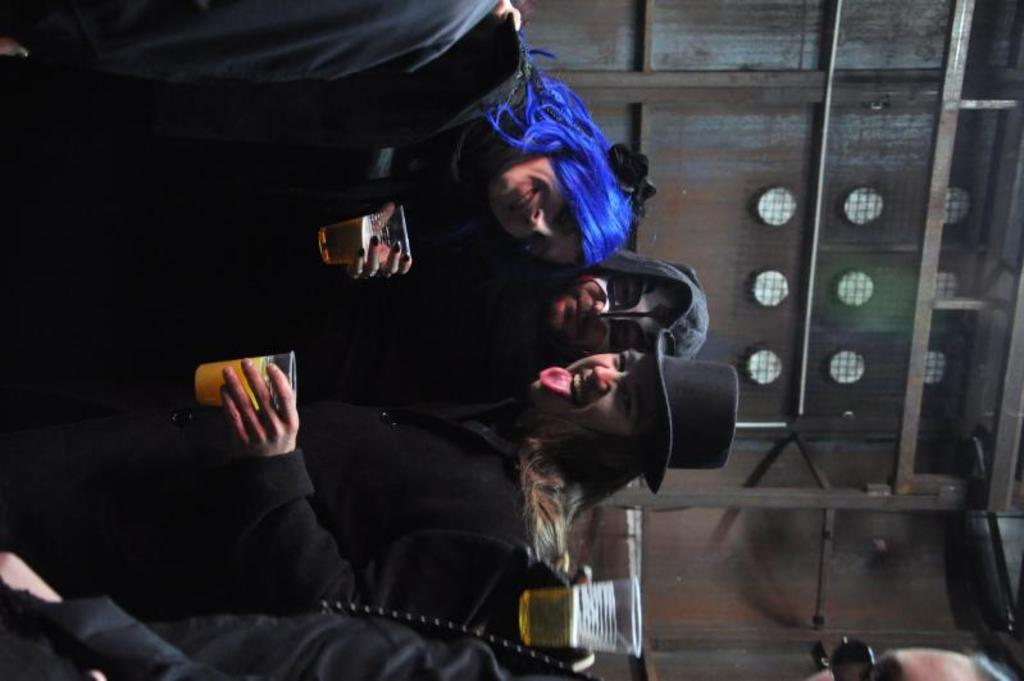What are the people in the image doing? The people in the image are standing and holding glasses. What can be seen in the background of the image? There are rods and a wall visible in the background of the image. What statement can be seen written on the rock in the image? There is no rock present in the image, and therefore no statement can be seen written on it. 